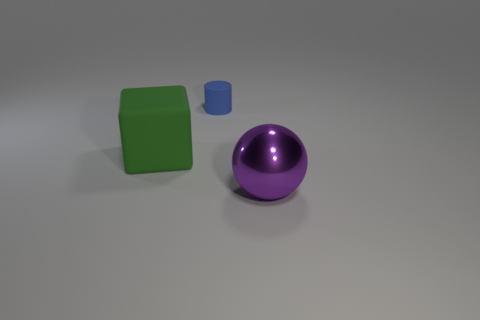Add 3 small purple metallic blocks. How many objects exist? 6 Subtract all blocks. How many objects are left? 2 Add 1 large purple metallic spheres. How many large purple metallic spheres are left? 2 Add 1 matte blocks. How many matte blocks exist? 2 Subtract 0 yellow cubes. How many objects are left? 3 Subtract all small blue cylinders. Subtract all purple metal spheres. How many objects are left? 1 